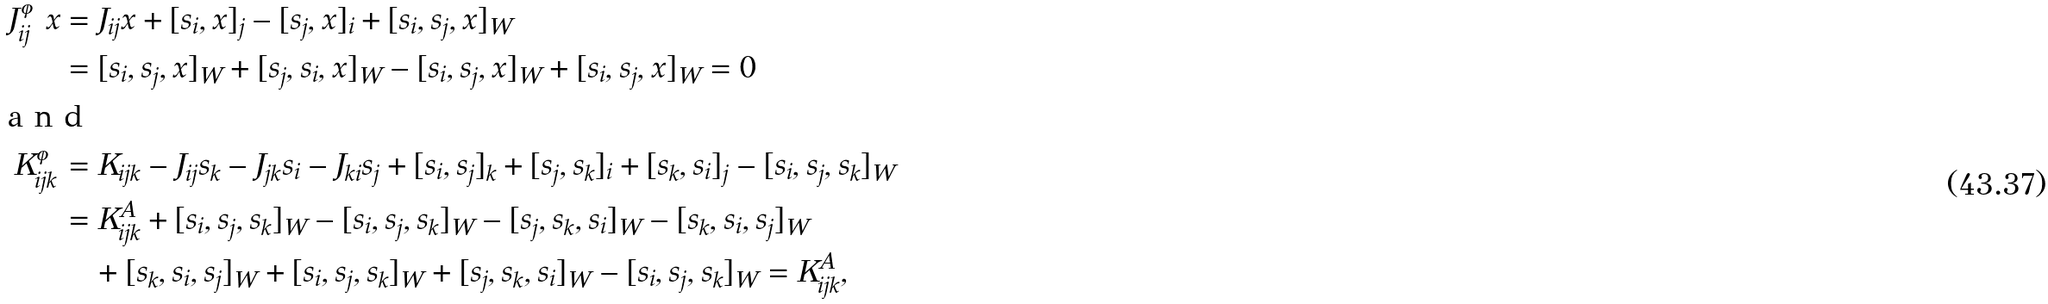Convert formula to latex. <formula><loc_0><loc_0><loc_500><loc_500>J ^ { \varphi } _ { i j } x & = J _ { i j } x + [ s _ { i } , x ] _ { j } - [ s _ { j } , x ] _ { i } + [ s _ { i } , s _ { j } , x ] _ { W } \\ & = [ s _ { i } , s _ { j } , x ] _ { W } + [ s _ { j } , s _ { i } , x ] _ { W } - [ s _ { i } , s _ { j } , x ] _ { W } + [ s _ { i } , s _ { j } , x ] _ { W } = 0 \\ \intertext { a n d } K ^ { \varphi } _ { i j k } & = K _ { i j k } - J _ { i j } s _ { k } - J _ { j k } s _ { i } - J _ { k i } s _ { j } + [ s _ { i } , s _ { j } ] _ { k } + [ s _ { j } , s _ { k } ] _ { i } + [ s _ { k } , s _ { i } ] _ { j } - [ s _ { i } , s _ { j } , s _ { k } ] _ { W } \\ & = K ^ { A } _ { i j k } + [ s _ { i } , s _ { j } , s _ { k } ] _ { W } - [ s _ { i } , s _ { j } , s _ { k } ] _ { W } - [ s _ { j } , s _ { k } , s _ { i } ] _ { W } - [ s _ { k } , s _ { i } , s _ { j } ] _ { W } \\ & \quad + [ s _ { k } , s _ { i } , s _ { j } ] _ { W } + [ s _ { i } , s _ { j } , s _ { k } ] _ { W } + [ s _ { j } , s _ { k } , s _ { i } ] _ { W } - [ s _ { i } , s _ { j } , s _ { k } ] _ { W } = K ^ { A } _ { i j k } ,</formula> 